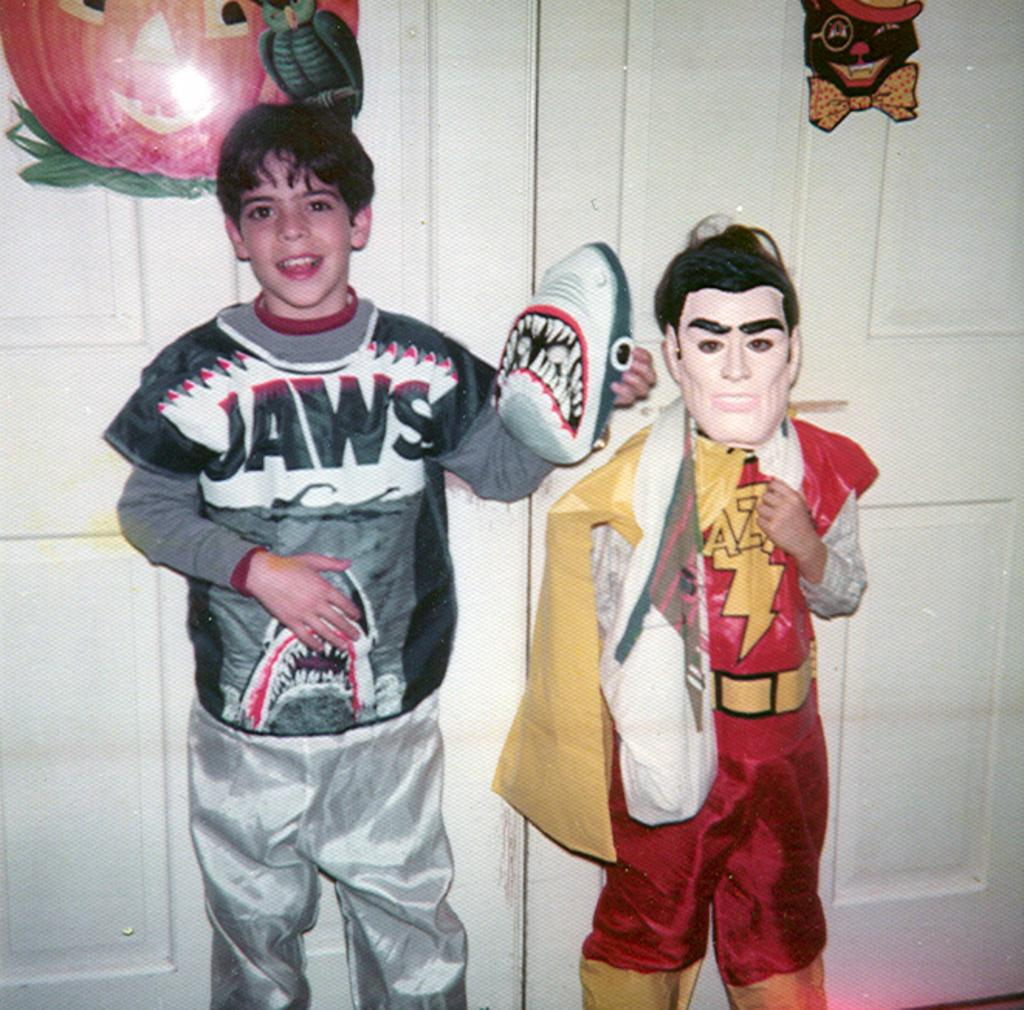<image>
Describe the image concisely. Two children dressed in costumes and one of them says Jaws. 